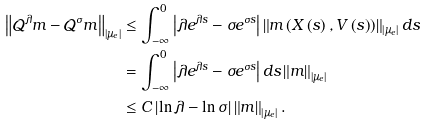<formula> <loc_0><loc_0><loc_500><loc_500>\left \| \mathcal { Q } ^ { \lambda } m - \mathcal { Q } ^ { \sigma } m \right \| _ { \left | \mu _ { e } \right | } & \leq \int _ { - \infty } ^ { 0 } \left | \lambda e ^ { \lambda s } - \sigma e ^ { \sigma s } \right | \left \| m \left ( X \left ( s \right ) , V \left ( s \right ) \right ) \right \| _ { \left | \mu _ { e } \right | } d s \\ & = \int _ { - \infty } ^ { 0 } \left | \lambda e ^ { \lambda s } - \sigma e ^ { \sigma s } \right | d s \left \| m \right \| _ { \left | \mu _ { e } \right | } \\ \, & \leq C \left | \ln \lambda - \ln \sigma \right | \left \| m \right \| _ { \left | \mu _ { e } \right | } .</formula> 